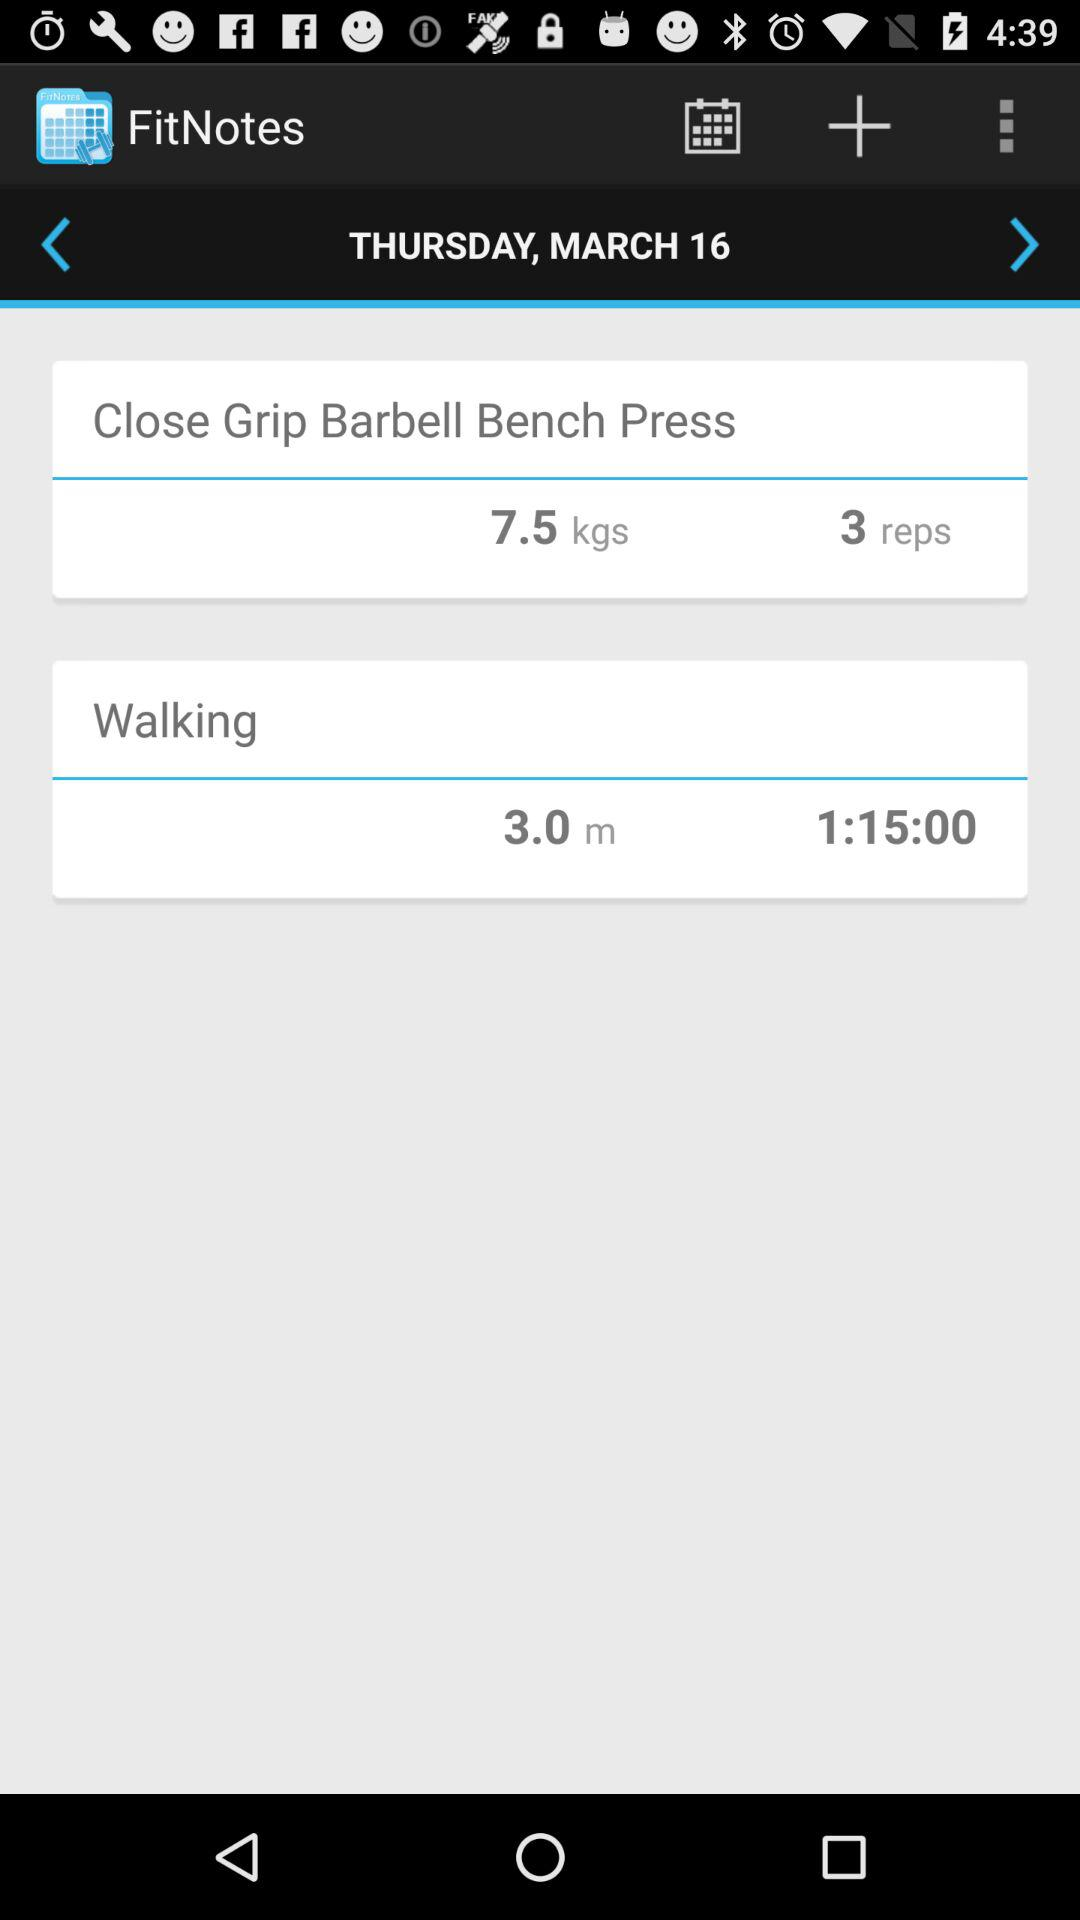What is the walking distance? The walking distance is 3.0 meters. 